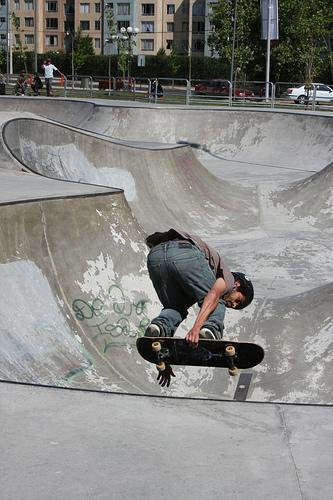How many bicycles are there?
Give a very brief answer. 0. How many people can you see?
Give a very brief answer. 1. 